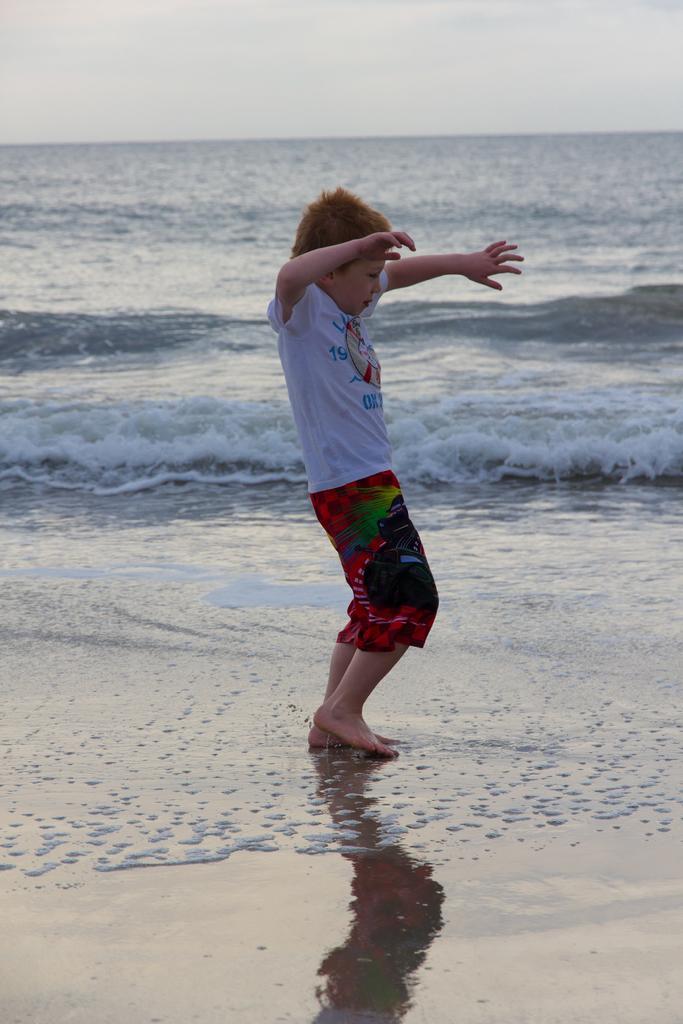Please provide a concise description of this image. In this image we can see the sea, one boy dancing near the sea, some wet sand on the bottom of the image and at the top there is the sky. 